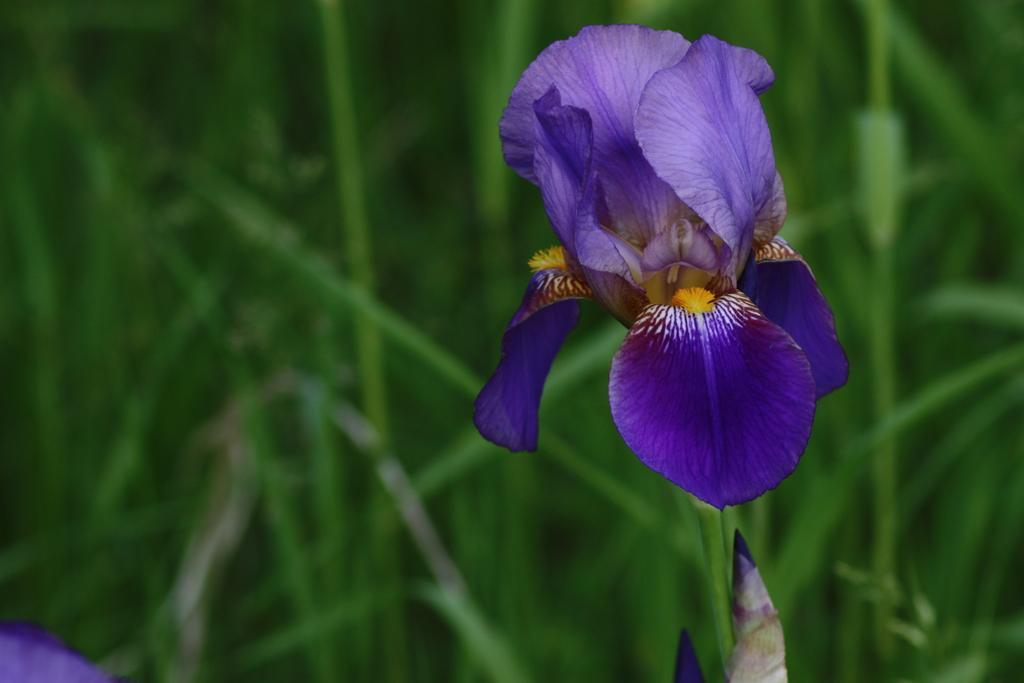Please provide a concise description of this image. In this image there is a flower and grass. 